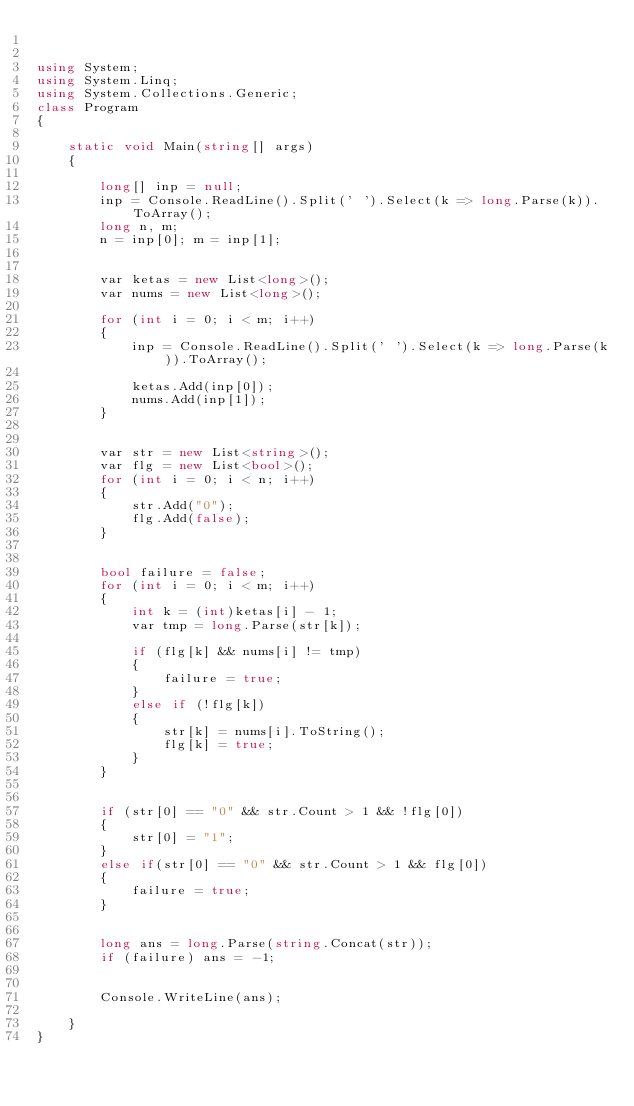<code> <loc_0><loc_0><loc_500><loc_500><_C#_>

using System;
using System.Linq;
using System.Collections.Generic;
class Program
{

    static void Main(string[] args)
    {

        long[] inp = null;
        inp = Console.ReadLine().Split(' ').Select(k => long.Parse(k)).ToArray();
        long n, m;
        n = inp[0]; m = inp[1];


        var ketas = new List<long>();
        var nums = new List<long>();

        for (int i = 0; i < m; i++)
        {
            inp = Console.ReadLine().Split(' ').Select(k => long.Parse(k)).ToArray();

            ketas.Add(inp[0]);
            nums.Add(inp[1]);
        }


        var str = new List<string>();
        var flg = new List<bool>();
        for (int i = 0; i < n; i++)
        {
            str.Add("0");
            flg.Add(false);
        }


        bool failure = false;
        for (int i = 0; i < m; i++)
        {
            int k = (int)ketas[i] - 1;
            var tmp = long.Parse(str[k]);

            if (flg[k] && nums[i] != tmp)
            {
                failure = true;
            }
            else if (!flg[k])
            {
                str[k] = nums[i].ToString();
                flg[k] = true;
            }
        }


        if (str[0] == "0" && str.Count > 1 && !flg[0])
        {
            str[0] = "1";
        }
        else if(str[0] == "0" && str.Count > 1 && flg[0])
        {
            failure = true;
        }


        long ans = long.Parse(string.Concat(str));
        if (failure) ans = -1;


        Console.WriteLine(ans);

    }
}
</code> 